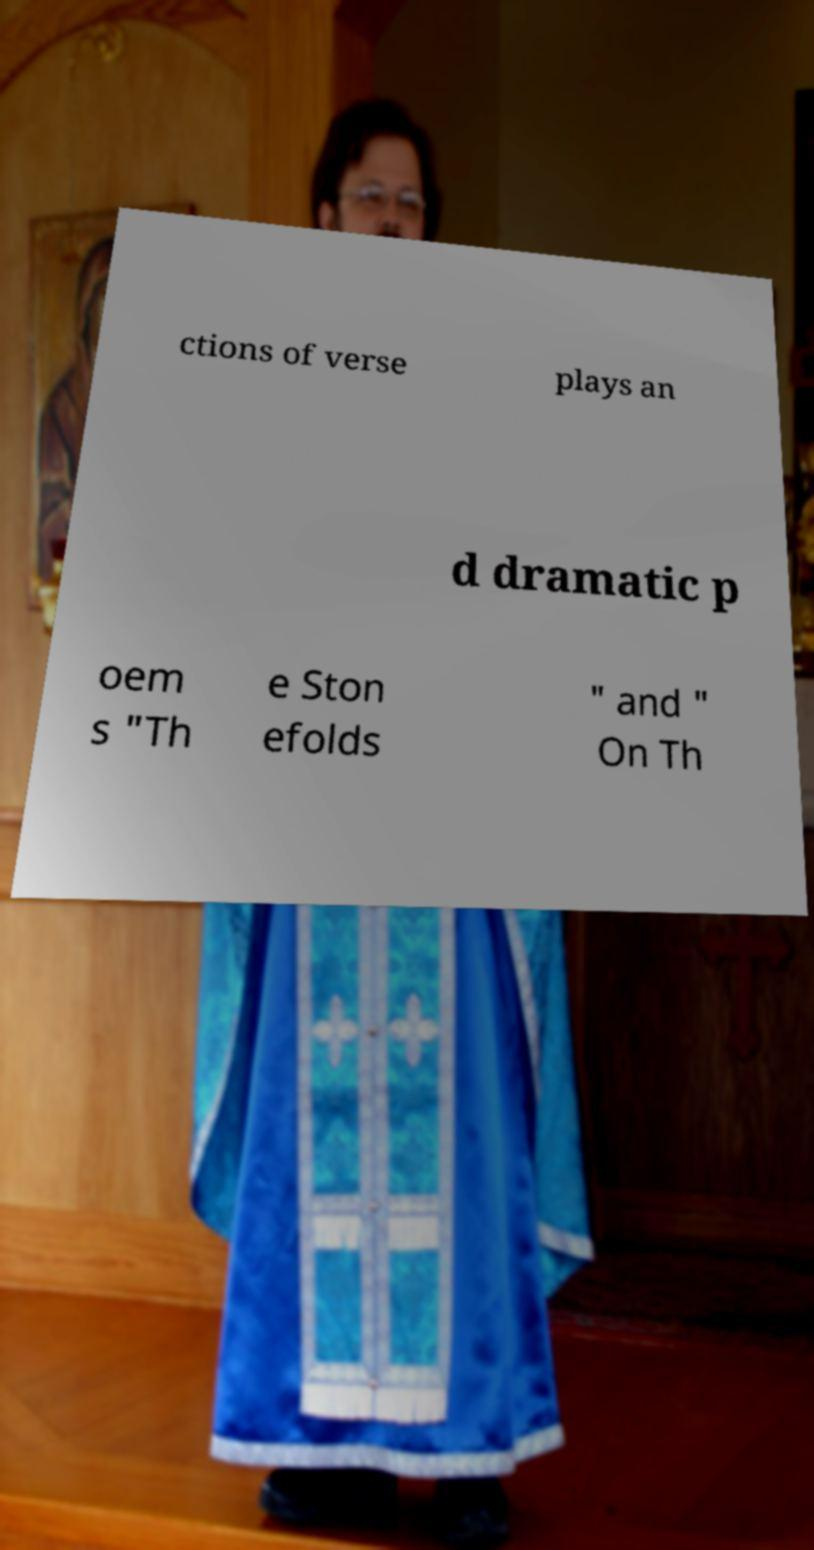There's text embedded in this image that I need extracted. Can you transcribe it verbatim? ctions of verse plays an d dramatic p oem s "Th e Ston efolds " and " On Th 